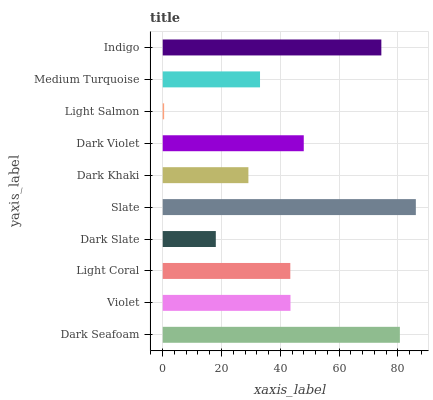Is Light Salmon the minimum?
Answer yes or no. Yes. Is Slate the maximum?
Answer yes or no. Yes. Is Violet the minimum?
Answer yes or no. No. Is Violet the maximum?
Answer yes or no. No. Is Dark Seafoam greater than Violet?
Answer yes or no. Yes. Is Violet less than Dark Seafoam?
Answer yes or no. Yes. Is Violet greater than Dark Seafoam?
Answer yes or no. No. Is Dark Seafoam less than Violet?
Answer yes or no. No. Is Violet the high median?
Answer yes or no. Yes. Is Light Coral the low median?
Answer yes or no. Yes. Is Dark Khaki the high median?
Answer yes or no. No. Is Light Salmon the low median?
Answer yes or no. No. 